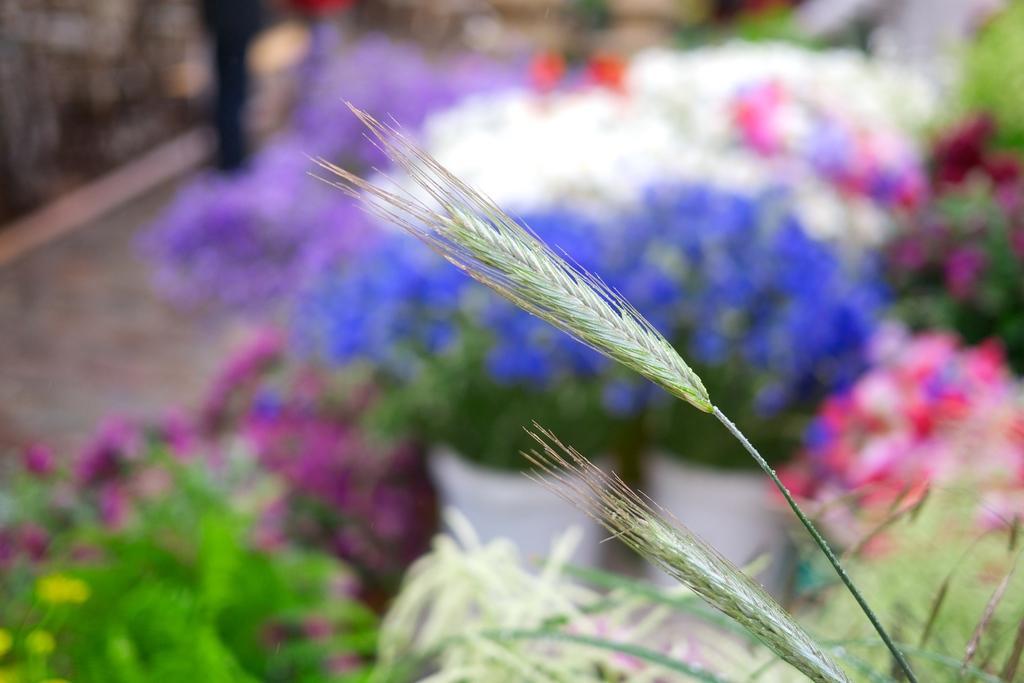Could you give a brief overview of what you see in this image? As we can see in the image are plants, flowers and the background is blurred. 